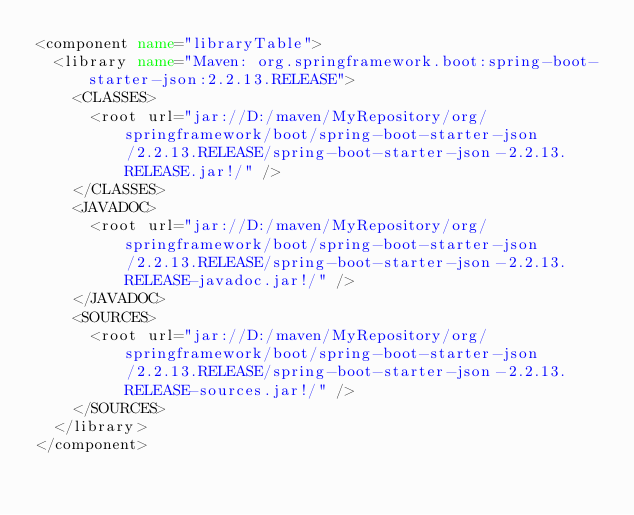<code> <loc_0><loc_0><loc_500><loc_500><_XML_><component name="libraryTable">
  <library name="Maven: org.springframework.boot:spring-boot-starter-json:2.2.13.RELEASE">
    <CLASSES>
      <root url="jar://D:/maven/MyRepository/org/springframework/boot/spring-boot-starter-json/2.2.13.RELEASE/spring-boot-starter-json-2.2.13.RELEASE.jar!/" />
    </CLASSES>
    <JAVADOC>
      <root url="jar://D:/maven/MyRepository/org/springframework/boot/spring-boot-starter-json/2.2.13.RELEASE/spring-boot-starter-json-2.2.13.RELEASE-javadoc.jar!/" />
    </JAVADOC>
    <SOURCES>
      <root url="jar://D:/maven/MyRepository/org/springframework/boot/spring-boot-starter-json/2.2.13.RELEASE/spring-boot-starter-json-2.2.13.RELEASE-sources.jar!/" />
    </SOURCES>
  </library>
</component></code> 